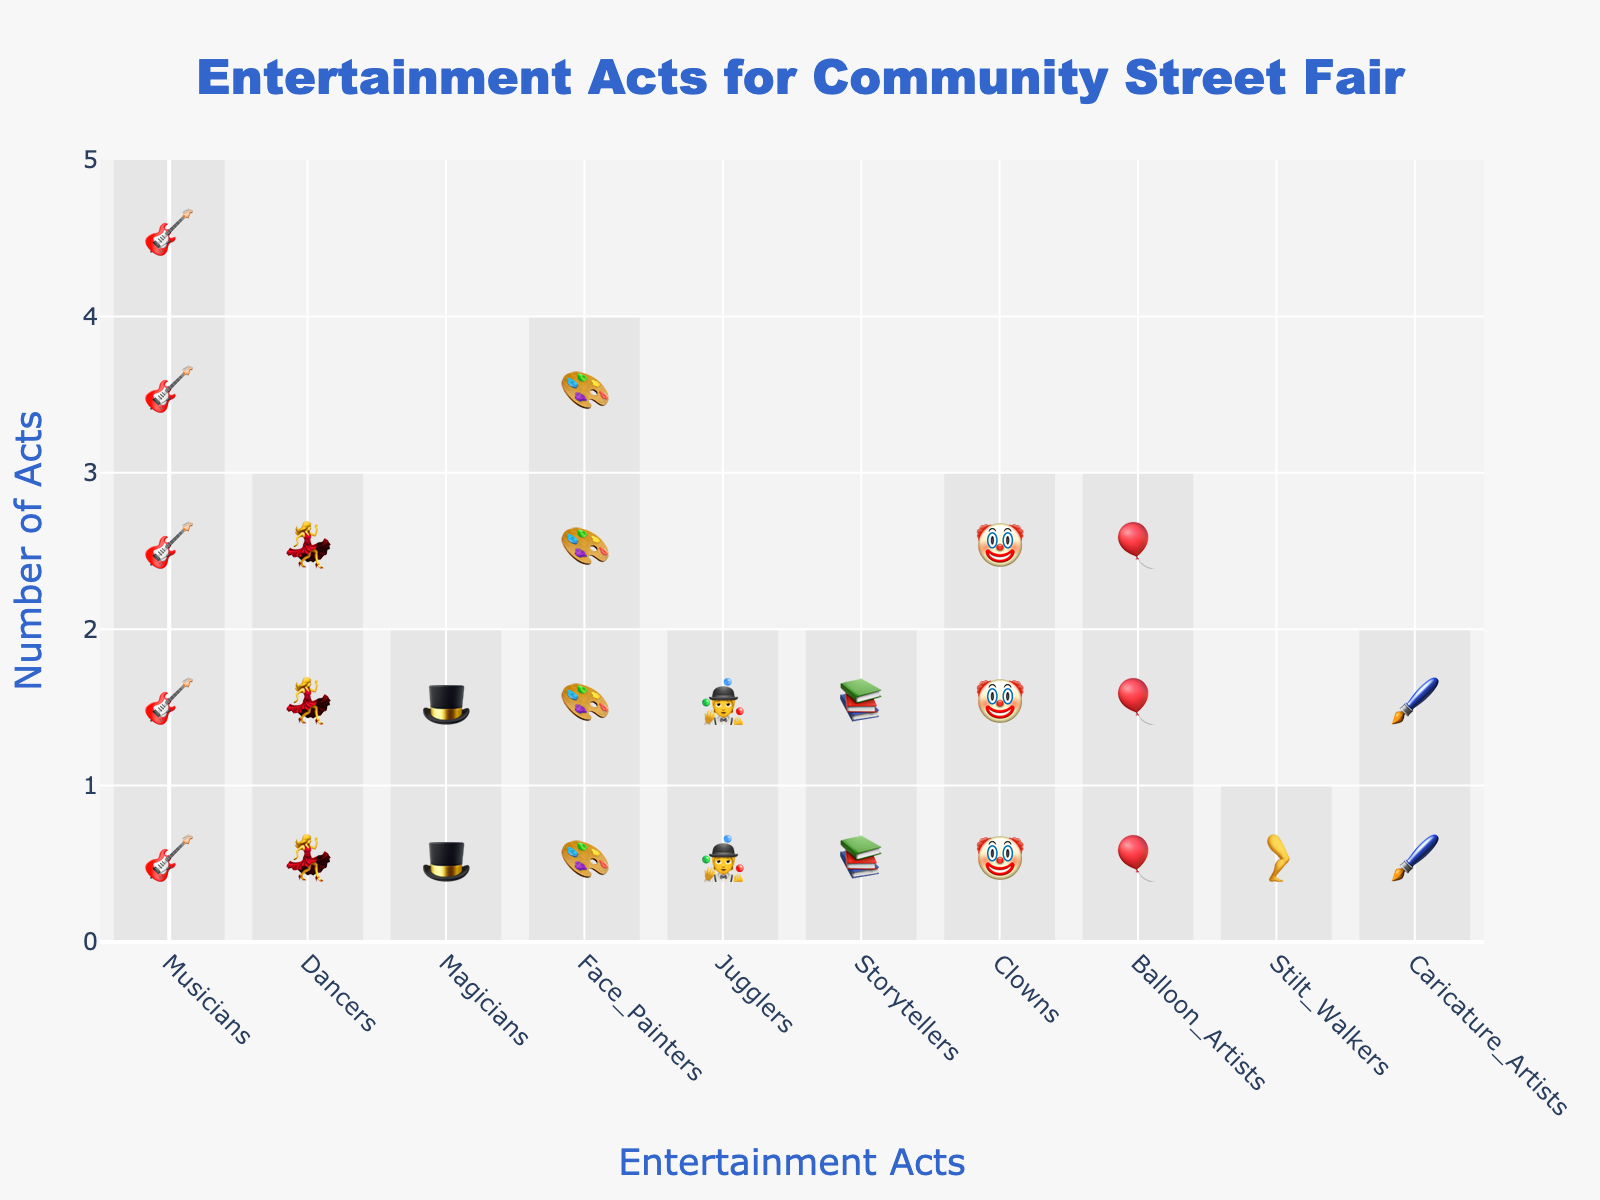What's the total number of entertainment acts scheduled for the street fair? To find the total number of acts, sum all the individual acts listed in the plot: 5 (Musicians) + 3 (Dancers) + 2 (Magicians) + 4 (Face Painters) + 2 (Jugglers) + 2 (Storytellers) + 3 (Clowns) + 3 (Balloon Artists) + 1 (Stilt Walkers) + 2 (Caricature Artists). The total is 27.
Answer: 27 Which entertainment act has the highest number of scheduled acts? From the plot, the bars corresponding to Musicians are the longest with 5 acts, which is the highest.
Answer: Musicians How many more Face Painters are there than Stilt Walkers? There are 4 Face Painters and 1 Stilt Walker. The difference is 4 - 1 = 3.
Answer: 3 What is the average number of acts per entertainment category? To find the average number of acts, add up all the acts and divide by the number of categories. The total number of acts is 27 and there are 10 categories. The average is 27 / 10 = 2.7.
Answer: 2.7 Are there any entertainment acts that have an equal number of performers and, if so, which ones? From the plot, Dancers (3), Clowns (3), and Balloon Artists (3) all have an equal number of performers, each with 3.
Answer: Dancers, Clowns, Balloon Artists How many categories have the exact same number of acts scheduled? Dancers, Clowns, and Balloon Artists each have 3 acts scheduled, and Magicians, Jugglers, Storytellers, and Caricature Artists each have 2 acts scheduled. So, two sets of categories have the same number of acts, totaling 7 categories.
Answer: 7 Which entertainment act has the lowest number of scheduled acts? The plot shows that Stilt Walkers have the shortest bar with only 1 act scheduled.
Answer: Stilt Walkers How many entertainment acts have more than 2 performers scheduled? From the plot, the acts with more than 2 performers are Musicians (5), Face Painters (4), Dancers (3), Clowns (3), and Balloon Artists (3). So, there are 5 such acts.
Answer: 5 What is the combined number of acts for Magicians, Jugglers, and Storytellers? Magicians have 2 acts, Jugglers have 2 acts, and Storytellers have 2 acts. The combined number is 2 + 2 + 2 = 6.
Answer: 6 